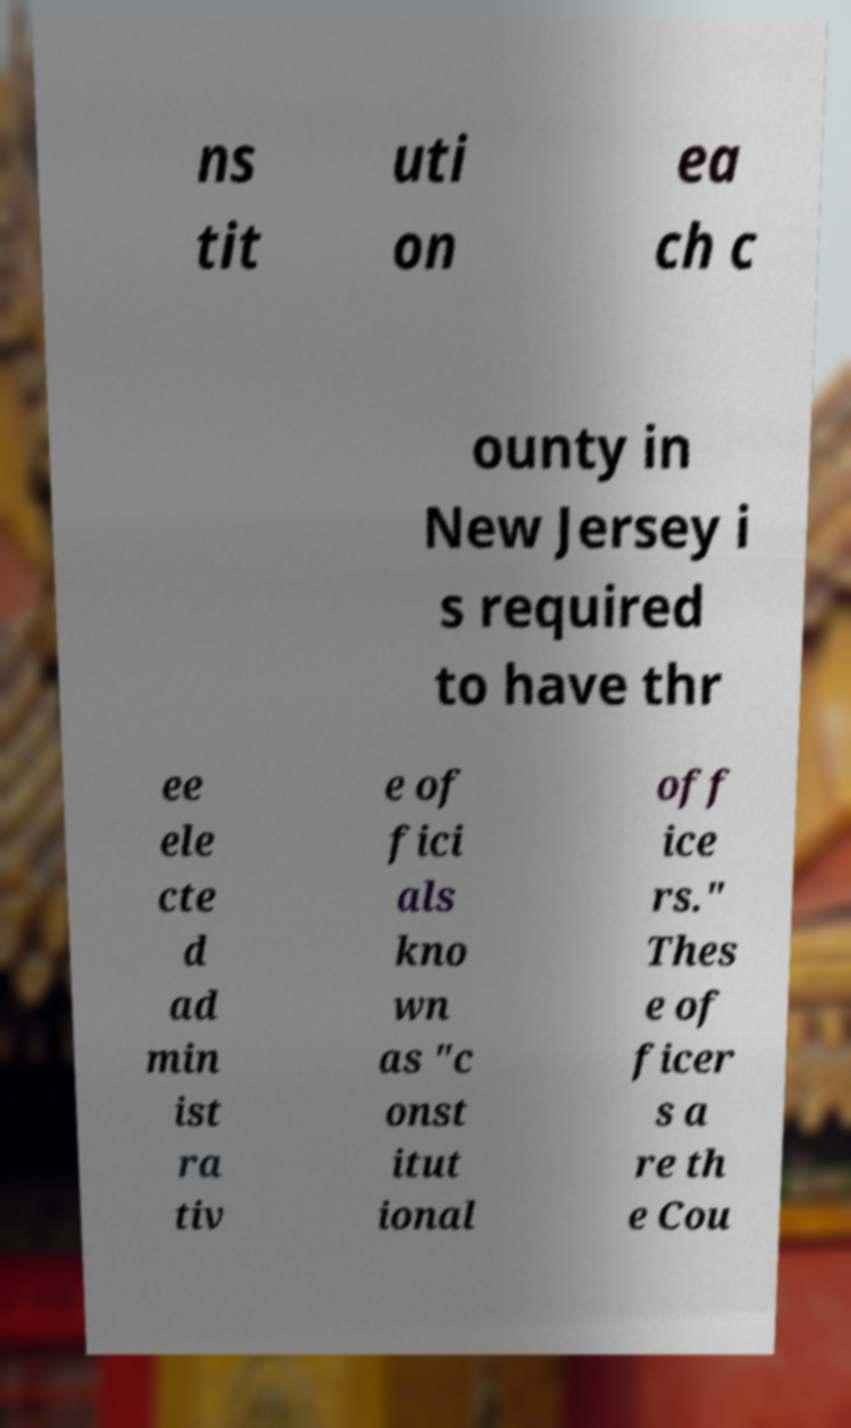Please identify and transcribe the text found in this image. ns tit uti on ea ch c ounty in New Jersey i s required to have thr ee ele cte d ad min ist ra tiv e of fici als kno wn as "c onst itut ional off ice rs." Thes e of ficer s a re th e Cou 